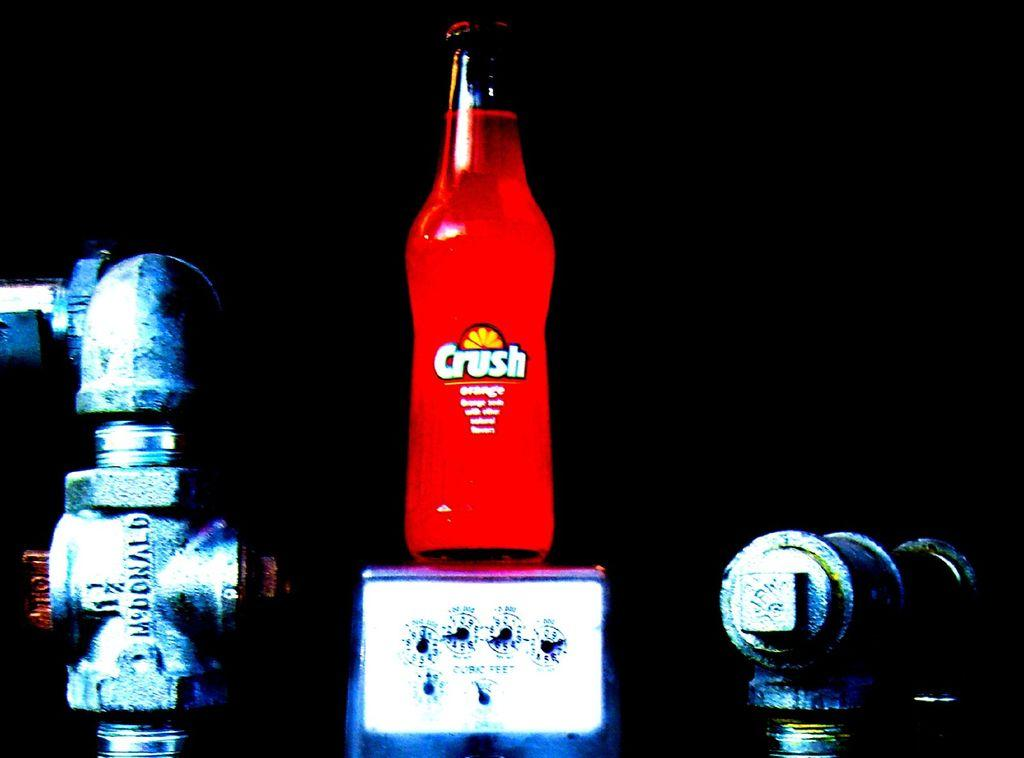<image>
Relay a brief, clear account of the picture shown. A crush orange soda is on top of a controller in a very dark room. 